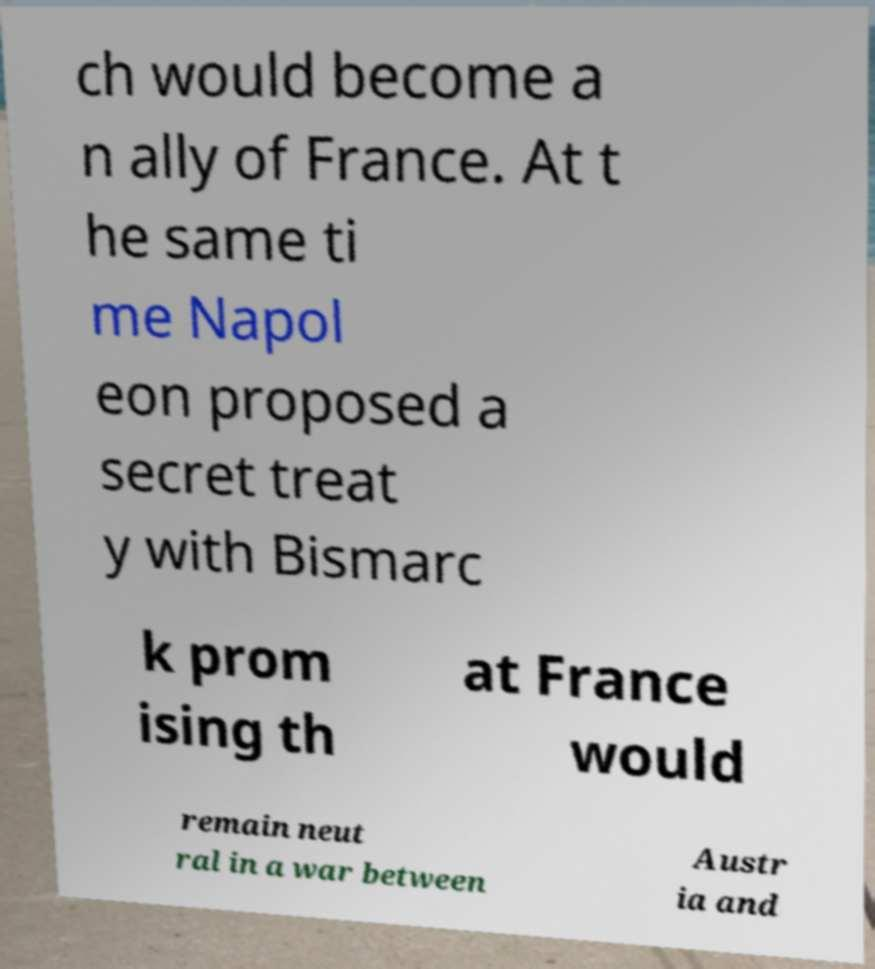For documentation purposes, I need the text within this image transcribed. Could you provide that? ch would become a n ally of France. At t he same ti me Napol eon proposed a secret treat y with Bismarc k prom ising th at France would remain neut ral in a war between Austr ia and 